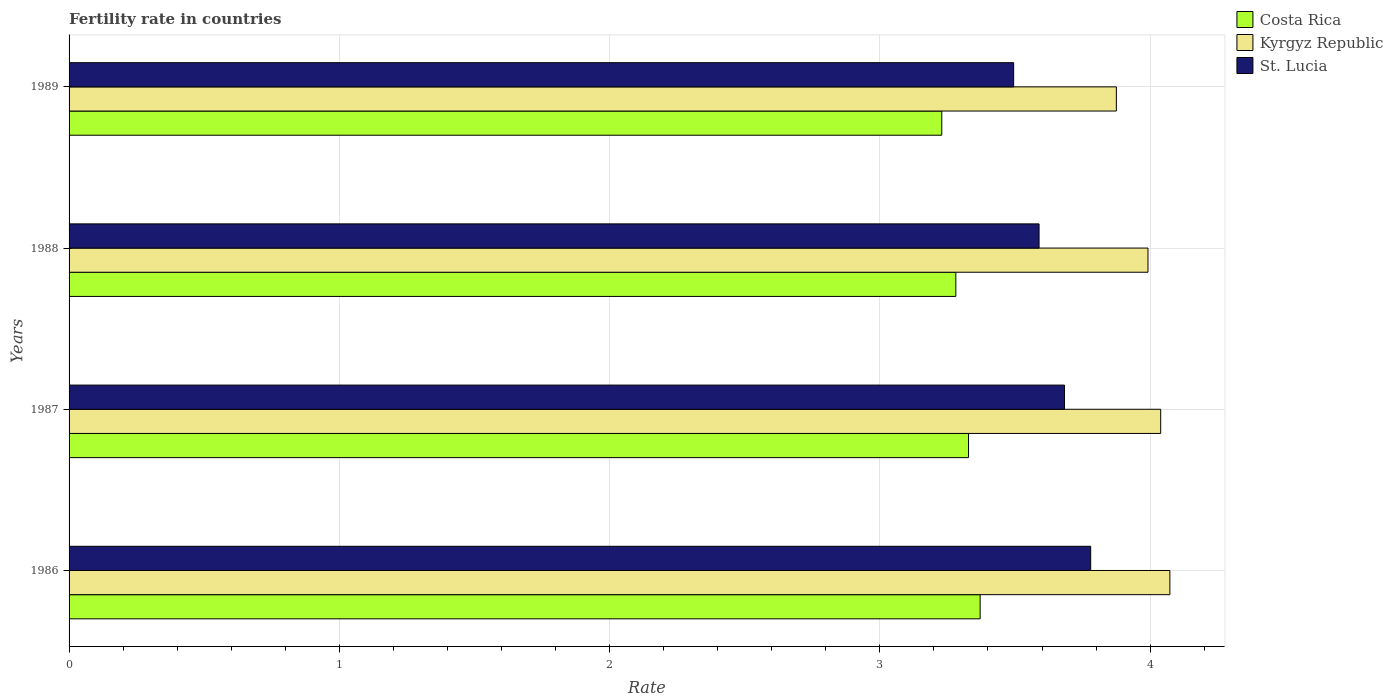How many different coloured bars are there?
Offer a very short reply. 3. Are the number of bars on each tick of the Y-axis equal?
Provide a short and direct response. Yes. How many bars are there on the 3rd tick from the bottom?
Your answer should be compact. 3. What is the fertility rate in St. Lucia in 1986?
Make the answer very short. 3.78. Across all years, what is the maximum fertility rate in St. Lucia?
Your answer should be very brief. 3.78. Across all years, what is the minimum fertility rate in Costa Rica?
Provide a succinct answer. 3.23. In which year was the fertility rate in Kyrgyz Republic minimum?
Provide a short and direct response. 1989. What is the total fertility rate in Costa Rica in the graph?
Give a very brief answer. 13.21. What is the difference between the fertility rate in St. Lucia in 1986 and that in 1987?
Offer a very short reply. 0.1. What is the difference between the fertility rate in Costa Rica in 1988 and the fertility rate in St. Lucia in 1986?
Keep it short and to the point. -0.5. What is the average fertility rate in Costa Rica per year?
Offer a very short reply. 3.3. In the year 1986, what is the difference between the fertility rate in St. Lucia and fertility rate in Kyrgyz Republic?
Give a very brief answer. -0.29. In how many years, is the fertility rate in Costa Rica greater than 2 ?
Provide a succinct answer. 4. What is the ratio of the fertility rate in Kyrgyz Republic in 1986 to that in 1989?
Make the answer very short. 1.05. Is the difference between the fertility rate in St. Lucia in 1987 and 1988 greater than the difference between the fertility rate in Kyrgyz Republic in 1987 and 1988?
Provide a short and direct response. Yes. What is the difference between the highest and the second highest fertility rate in Kyrgyz Republic?
Your answer should be compact. 0.03. What is the difference between the highest and the lowest fertility rate in St. Lucia?
Offer a terse response. 0.28. In how many years, is the fertility rate in Costa Rica greater than the average fertility rate in Costa Rica taken over all years?
Your answer should be compact. 2. Is the sum of the fertility rate in Kyrgyz Republic in 1987 and 1988 greater than the maximum fertility rate in Costa Rica across all years?
Your answer should be very brief. Yes. What does the 2nd bar from the top in 1987 represents?
Your answer should be very brief. Kyrgyz Republic. What does the 3rd bar from the bottom in 1988 represents?
Offer a terse response. St. Lucia. How many bars are there?
Your response must be concise. 12. Does the graph contain grids?
Give a very brief answer. Yes. How are the legend labels stacked?
Offer a very short reply. Vertical. What is the title of the graph?
Provide a short and direct response. Fertility rate in countries. What is the label or title of the X-axis?
Ensure brevity in your answer.  Rate. What is the label or title of the Y-axis?
Provide a short and direct response. Years. What is the Rate of Costa Rica in 1986?
Your response must be concise. 3.37. What is the Rate in Kyrgyz Republic in 1986?
Your answer should be compact. 4.07. What is the Rate in St. Lucia in 1986?
Keep it short and to the point. 3.78. What is the Rate in Costa Rica in 1987?
Provide a succinct answer. 3.33. What is the Rate of Kyrgyz Republic in 1987?
Keep it short and to the point. 4.04. What is the Rate of St. Lucia in 1987?
Keep it short and to the point. 3.68. What is the Rate of Costa Rica in 1988?
Provide a succinct answer. 3.28. What is the Rate of Kyrgyz Republic in 1988?
Your response must be concise. 3.99. What is the Rate of St. Lucia in 1988?
Provide a succinct answer. 3.59. What is the Rate of Costa Rica in 1989?
Provide a succinct answer. 3.23. What is the Rate of Kyrgyz Republic in 1989?
Ensure brevity in your answer.  3.88. What is the Rate in St. Lucia in 1989?
Your answer should be very brief. 3.5. Across all years, what is the maximum Rate in Costa Rica?
Offer a terse response. 3.37. Across all years, what is the maximum Rate in Kyrgyz Republic?
Your response must be concise. 4.07. Across all years, what is the maximum Rate of St. Lucia?
Your answer should be very brief. 3.78. Across all years, what is the minimum Rate of Costa Rica?
Give a very brief answer. 3.23. Across all years, what is the minimum Rate of Kyrgyz Republic?
Your answer should be compact. 3.88. Across all years, what is the minimum Rate in St. Lucia?
Provide a short and direct response. 3.5. What is the total Rate of Costa Rica in the graph?
Give a very brief answer. 13.21. What is the total Rate in Kyrgyz Republic in the graph?
Your answer should be very brief. 15.98. What is the total Rate in St. Lucia in the graph?
Offer a very short reply. 14.55. What is the difference between the Rate in Costa Rica in 1986 and that in 1987?
Give a very brief answer. 0.04. What is the difference between the Rate in Kyrgyz Republic in 1986 and that in 1987?
Your answer should be compact. 0.03. What is the difference between the Rate in St. Lucia in 1986 and that in 1987?
Give a very brief answer. 0.1. What is the difference between the Rate in Costa Rica in 1986 and that in 1988?
Give a very brief answer. 0.09. What is the difference between the Rate of Kyrgyz Republic in 1986 and that in 1988?
Give a very brief answer. 0.08. What is the difference between the Rate in St. Lucia in 1986 and that in 1988?
Give a very brief answer. 0.19. What is the difference between the Rate of Costa Rica in 1986 and that in 1989?
Provide a short and direct response. 0.14. What is the difference between the Rate of Kyrgyz Republic in 1986 and that in 1989?
Offer a terse response. 0.2. What is the difference between the Rate of St. Lucia in 1986 and that in 1989?
Give a very brief answer. 0.28. What is the difference between the Rate of Costa Rica in 1987 and that in 1988?
Offer a terse response. 0.05. What is the difference between the Rate of Kyrgyz Republic in 1987 and that in 1988?
Offer a very short reply. 0.05. What is the difference between the Rate of St. Lucia in 1987 and that in 1988?
Provide a short and direct response. 0.09. What is the difference between the Rate of Costa Rica in 1987 and that in 1989?
Make the answer very short. 0.1. What is the difference between the Rate of Kyrgyz Republic in 1987 and that in 1989?
Offer a terse response. 0.16. What is the difference between the Rate of St. Lucia in 1987 and that in 1989?
Make the answer very short. 0.19. What is the difference between the Rate of Costa Rica in 1988 and that in 1989?
Provide a short and direct response. 0.05. What is the difference between the Rate in Kyrgyz Republic in 1988 and that in 1989?
Offer a terse response. 0.12. What is the difference between the Rate in St. Lucia in 1988 and that in 1989?
Provide a succinct answer. 0.09. What is the difference between the Rate in Costa Rica in 1986 and the Rate in Kyrgyz Republic in 1987?
Make the answer very short. -0.67. What is the difference between the Rate in Costa Rica in 1986 and the Rate in St. Lucia in 1987?
Make the answer very short. -0.31. What is the difference between the Rate of Kyrgyz Republic in 1986 and the Rate of St. Lucia in 1987?
Keep it short and to the point. 0.39. What is the difference between the Rate of Costa Rica in 1986 and the Rate of Kyrgyz Republic in 1988?
Your response must be concise. -0.62. What is the difference between the Rate in Costa Rica in 1986 and the Rate in St. Lucia in 1988?
Your answer should be very brief. -0.22. What is the difference between the Rate in Kyrgyz Republic in 1986 and the Rate in St. Lucia in 1988?
Provide a succinct answer. 0.48. What is the difference between the Rate of Costa Rica in 1986 and the Rate of Kyrgyz Republic in 1989?
Your answer should be compact. -0.5. What is the difference between the Rate in Costa Rica in 1986 and the Rate in St. Lucia in 1989?
Your answer should be very brief. -0.12. What is the difference between the Rate of Kyrgyz Republic in 1986 and the Rate of St. Lucia in 1989?
Provide a succinct answer. 0.58. What is the difference between the Rate in Costa Rica in 1987 and the Rate in Kyrgyz Republic in 1988?
Ensure brevity in your answer.  -0.66. What is the difference between the Rate in Costa Rica in 1987 and the Rate in St. Lucia in 1988?
Keep it short and to the point. -0.26. What is the difference between the Rate of Kyrgyz Republic in 1987 and the Rate of St. Lucia in 1988?
Make the answer very short. 0.45. What is the difference between the Rate in Costa Rica in 1987 and the Rate in Kyrgyz Republic in 1989?
Offer a terse response. -0.55. What is the difference between the Rate in Costa Rica in 1987 and the Rate in St. Lucia in 1989?
Offer a terse response. -0.17. What is the difference between the Rate in Kyrgyz Republic in 1987 and the Rate in St. Lucia in 1989?
Keep it short and to the point. 0.54. What is the difference between the Rate of Costa Rica in 1988 and the Rate of Kyrgyz Republic in 1989?
Provide a short and direct response. -0.59. What is the difference between the Rate in Costa Rica in 1988 and the Rate in St. Lucia in 1989?
Your answer should be compact. -0.21. What is the difference between the Rate of Kyrgyz Republic in 1988 and the Rate of St. Lucia in 1989?
Make the answer very short. 0.5. What is the average Rate of Costa Rica per year?
Make the answer very short. 3.3. What is the average Rate in Kyrgyz Republic per year?
Your answer should be very brief. 3.99. What is the average Rate of St. Lucia per year?
Offer a very short reply. 3.64. In the year 1986, what is the difference between the Rate of Costa Rica and Rate of Kyrgyz Republic?
Keep it short and to the point. -0.7. In the year 1986, what is the difference between the Rate of Costa Rica and Rate of St. Lucia?
Give a very brief answer. -0.41. In the year 1986, what is the difference between the Rate of Kyrgyz Republic and Rate of St. Lucia?
Offer a very short reply. 0.29. In the year 1987, what is the difference between the Rate in Costa Rica and Rate in Kyrgyz Republic?
Keep it short and to the point. -0.71. In the year 1987, what is the difference between the Rate in Costa Rica and Rate in St. Lucia?
Provide a short and direct response. -0.35. In the year 1987, what is the difference between the Rate in Kyrgyz Republic and Rate in St. Lucia?
Provide a succinct answer. 0.36. In the year 1988, what is the difference between the Rate of Costa Rica and Rate of Kyrgyz Republic?
Provide a short and direct response. -0.71. In the year 1988, what is the difference between the Rate in Costa Rica and Rate in St. Lucia?
Offer a very short reply. -0.31. In the year 1988, what is the difference between the Rate of Kyrgyz Republic and Rate of St. Lucia?
Provide a short and direct response. 0.4. In the year 1989, what is the difference between the Rate in Costa Rica and Rate in Kyrgyz Republic?
Give a very brief answer. -0.65. In the year 1989, what is the difference between the Rate in Costa Rica and Rate in St. Lucia?
Provide a succinct answer. -0.27. In the year 1989, what is the difference between the Rate of Kyrgyz Republic and Rate of St. Lucia?
Ensure brevity in your answer.  0.38. What is the ratio of the Rate in Costa Rica in 1986 to that in 1987?
Offer a very short reply. 1.01. What is the ratio of the Rate in Kyrgyz Republic in 1986 to that in 1987?
Ensure brevity in your answer.  1.01. What is the ratio of the Rate of St. Lucia in 1986 to that in 1987?
Provide a succinct answer. 1.03. What is the ratio of the Rate of Costa Rica in 1986 to that in 1988?
Make the answer very short. 1.03. What is the ratio of the Rate of Kyrgyz Republic in 1986 to that in 1988?
Your response must be concise. 1.02. What is the ratio of the Rate of St. Lucia in 1986 to that in 1988?
Ensure brevity in your answer.  1.05. What is the ratio of the Rate in Costa Rica in 1986 to that in 1989?
Your answer should be compact. 1.04. What is the ratio of the Rate of Kyrgyz Republic in 1986 to that in 1989?
Provide a succinct answer. 1.05. What is the ratio of the Rate of St. Lucia in 1986 to that in 1989?
Provide a short and direct response. 1.08. What is the ratio of the Rate of Costa Rica in 1987 to that in 1988?
Ensure brevity in your answer.  1.01. What is the ratio of the Rate of Kyrgyz Republic in 1987 to that in 1988?
Provide a succinct answer. 1.01. What is the ratio of the Rate of St. Lucia in 1987 to that in 1988?
Provide a succinct answer. 1.03. What is the ratio of the Rate in Costa Rica in 1987 to that in 1989?
Offer a terse response. 1.03. What is the ratio of the Rate in Kyrgyz Republic in 1987 to that in 1989?
Your answer should be compact. 1.04. What is the ratio of the Rate of St. Lucia in 1987 to that in 1989?
Give a very brief answer. 1.05. What is the ratio of the Rate of Costa Rica in 1988 to that in 1989?
Give a very brief answer. 1.02. What is the ratio of the Rate in Kyrgyz Republic in 1988 to that in 1989?
Ensure brevity in your answer.  1.03. What is the ratio of the Rate in St. Lucia in 1988 to that in 1989?
Your answer should be very brief. 1.03. What is the difference between the highest and the second highest Rate in Costa Rica?
Give a very brief answer. 0.04. What is the difference between the highest and the second highest Rate of Kyrgyz Republic?
Give a very brief answer. 0.03. What is the difference between the highest and the second highest Rate in St. Lucia?
Ensure brevity in your answer.  0.1. What is the difference between the highest and the lowest Rate in Costa Rica?
Your response must be concise. 0.14. What is the difference between the highest and the lowest Rate in Kyrgyz Republic?
Your answer should be very brief. 0.2. What is the difference between the highest and the lowest Rate in St. Lucia?
Your response must be concise. 0.28. 